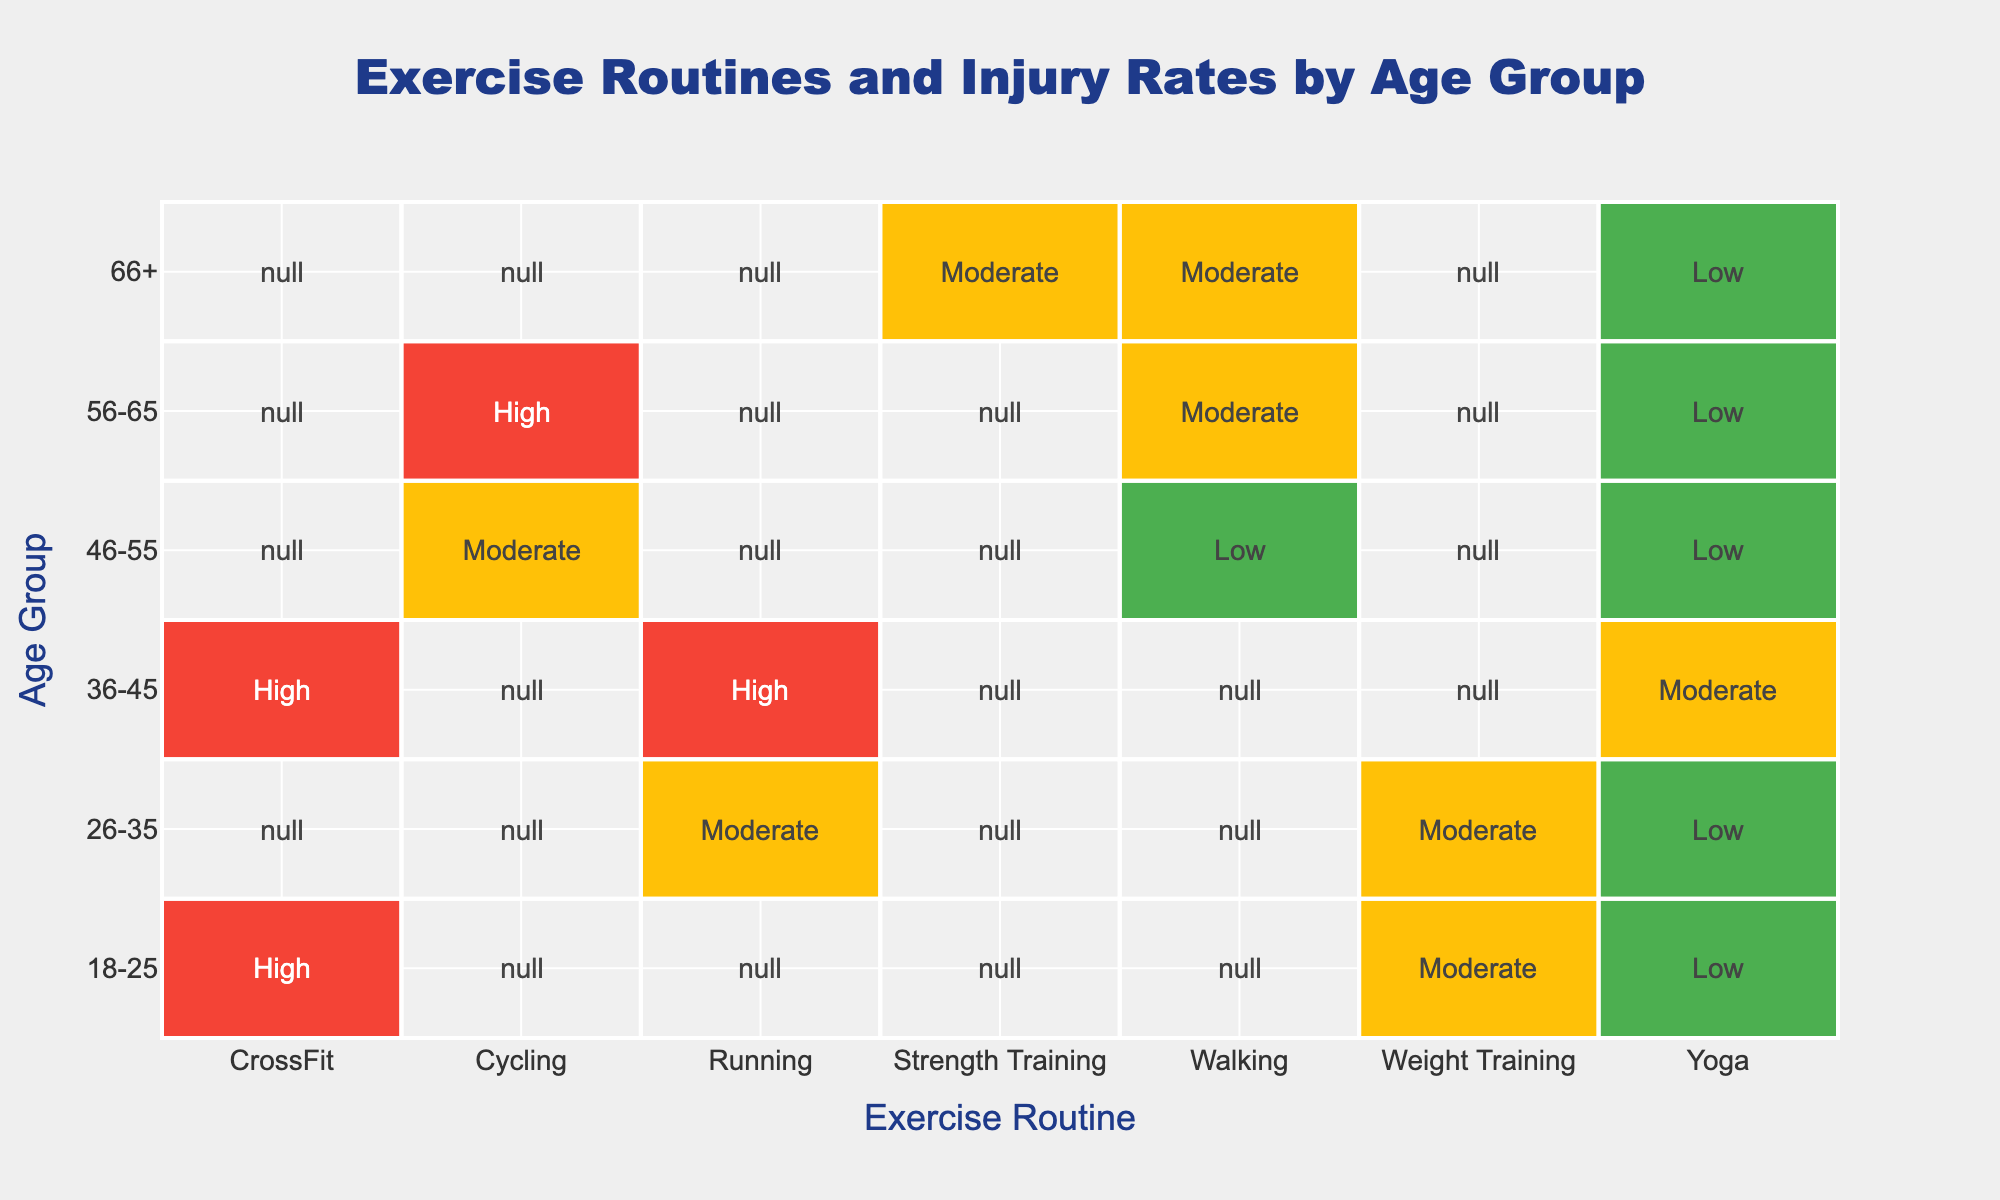What is the injury incidence for Yoga in the age group 18-25? The table shows that for the age group 18-25 and the exercise routine Yoga, the injury incidence is labeled as Low.
Answer: Low For which age group is the injury incidence for CrossFit the highest? Looking at the table, CrossFit has a High injury incidence in both the 18-25 and the 36-45 age groups. Since it appears in both, the answer reflects this based on the data provided.
Answer: 18-25 and 36-45 What is the average injury incidence for the Running exercise routine across all age groups? The table indicates that the injury incidences for Running are Moderate for 26-35 and High for 36-45. To find the average, we convert Low to 1, Moderate to 2, and High to 3. Thus, (2 + 3)/2 = 2.5 corresponds to an average injury incidence between Moderate and High.
Answer: Moderate Is there a difference in injury incidence for Yoga between the age groups 46-55 and 56-65? The table shows that both 46-55 and 56-65 age groups have a Low injury incidence for Yoga. Therefore, there is no difference in injury incidence between these two age groups for the Yoga exercise routine.
Answer: No Which exercise routine has the highest injury incidence for the age group 36-45? According to the table, for the age group 36-45, both Running and CrossFit have a High injury incidence. Therefore, both of these exercise routines share the highest injury incidence status for this age group.
Answer: Running and CrossFit What can be inferred about the relationship between age groups and injury risk for Weight Training? Looking at the data for Weight Training across age groups, it shows Moderate injury incidence for both 18-25 and 26-35 and no injury incidence reported for older age groups. Thus, younger groups seem more prone to injury when performing Weight Training.
Answer: Younger groups have higher injury risk 